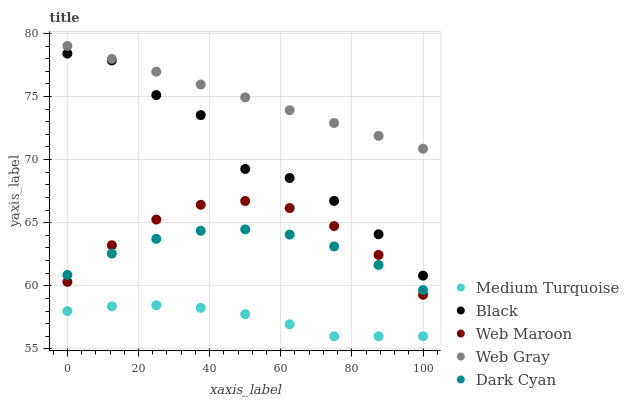Does Medium Turquoise have the minimum area under the curve?
Answer yes or no. Yes. Does Web Gray have the maximum area under the curve?
Answer yes or no. Yes. Does Web Maroon have the minimum area under the curve?
Answer yes or no. No. Does Web Maroon have the maximum area under the curve?
Answer yes or no. No. Is Web Gray the smoothest?
Answer yes or no. Yes. Is Black the roughest?
Answer yes or no. Yes. Is Web Maroon the smoothest?
Answer yes or no. No. Is Web Maroon the roughest?
Answer yes or no. No. Does Medium Turquoise have the lowest value?
Answer yes or no. Yes. Does Web Maroon have the lowest value?
Answer yes or no. No. Does Web Gray have the highest value?
Answer yes or no. Yes. Does Web Maroon have the highest value?
Answer yes or no. No. Is Medium Turquoise less than Web Maroon?
Answer yes or no. Yes. Is Black greater than Web Maroon?
Answer yes or no. Yes. Does Web Maroon intersect Dark Cyan?
Answer yes or no. Yes. Is Web Maroon less than Dark Cyan?
Answer yes or no. No. Is Web Maroon greater than Dark Cyan?
Answer yes or no. No. Does Medium Turquoise intersect Web Maroon?
Answer yes or no. No. 